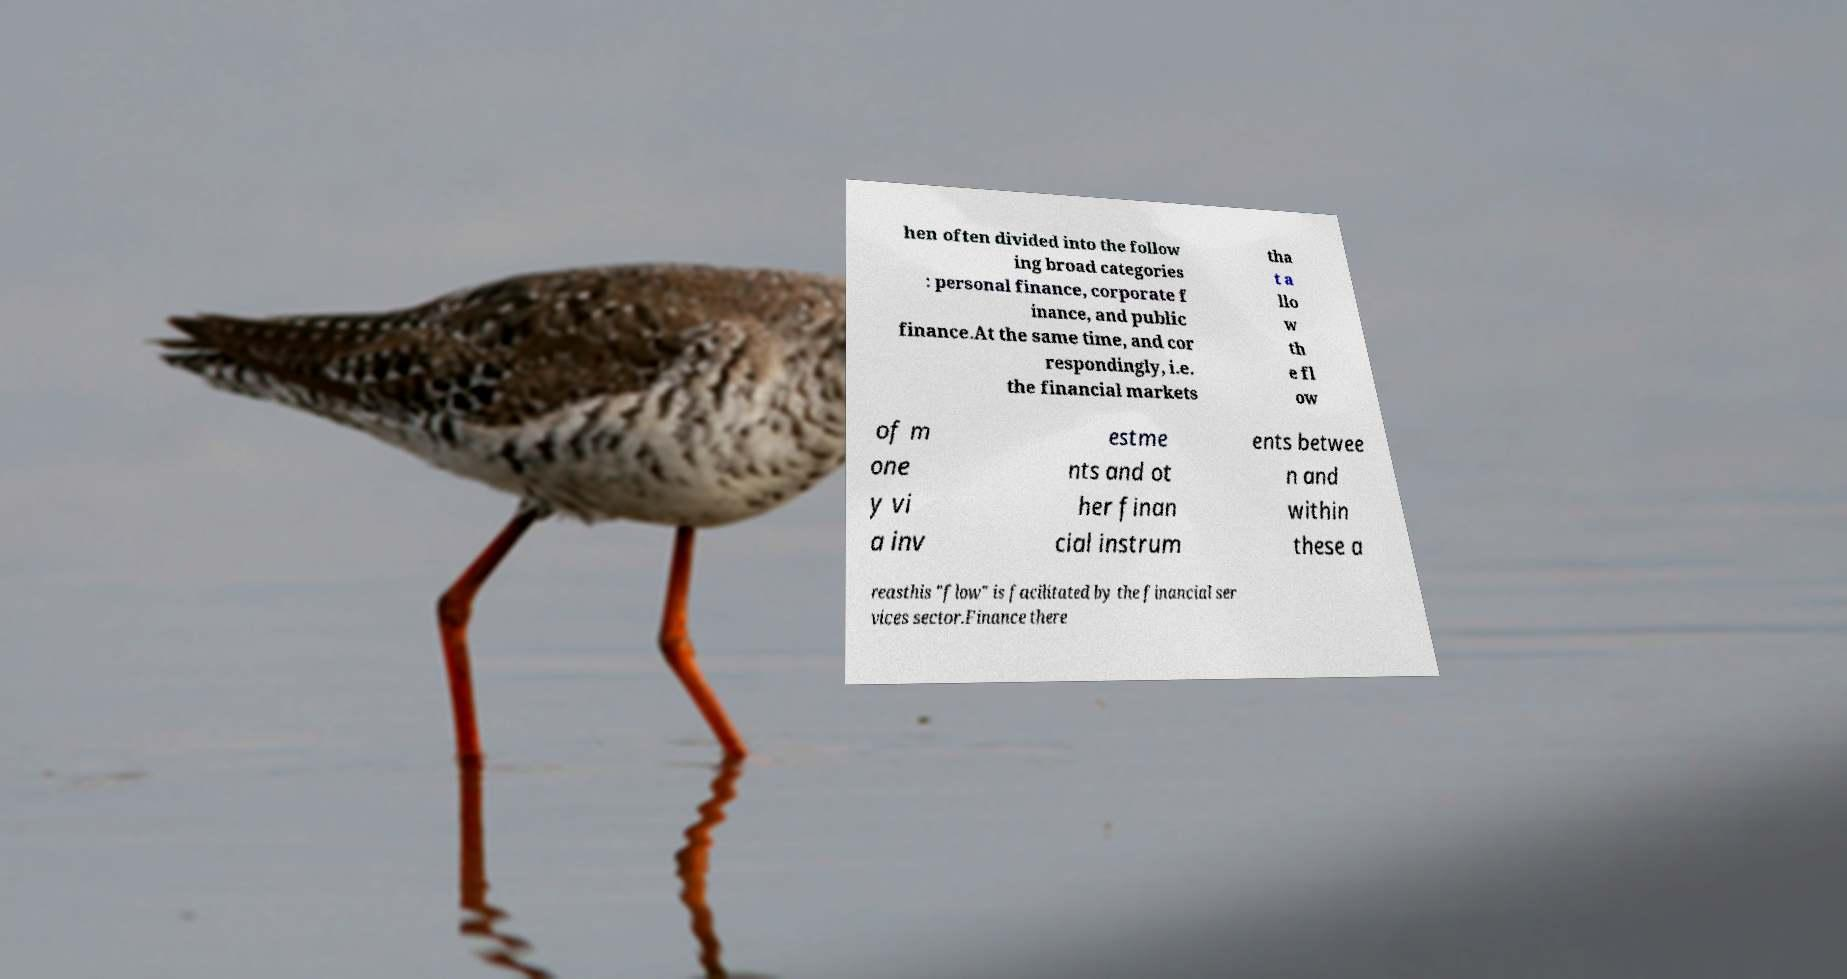Please read and relay the text visible in this image. What does it say? hen often divided into the follow ing broad categories : personal finance, corporate f inance, and public finance.At the same time, and cor respondingly, i.e. the financial markets tha t a llo w th e fl ow of m one y vi a inv estme nts and ot her finan cial instrum ents betwee n and within these a reasthis "flow" is facilitated by the financial ser vices sector.Finance there 